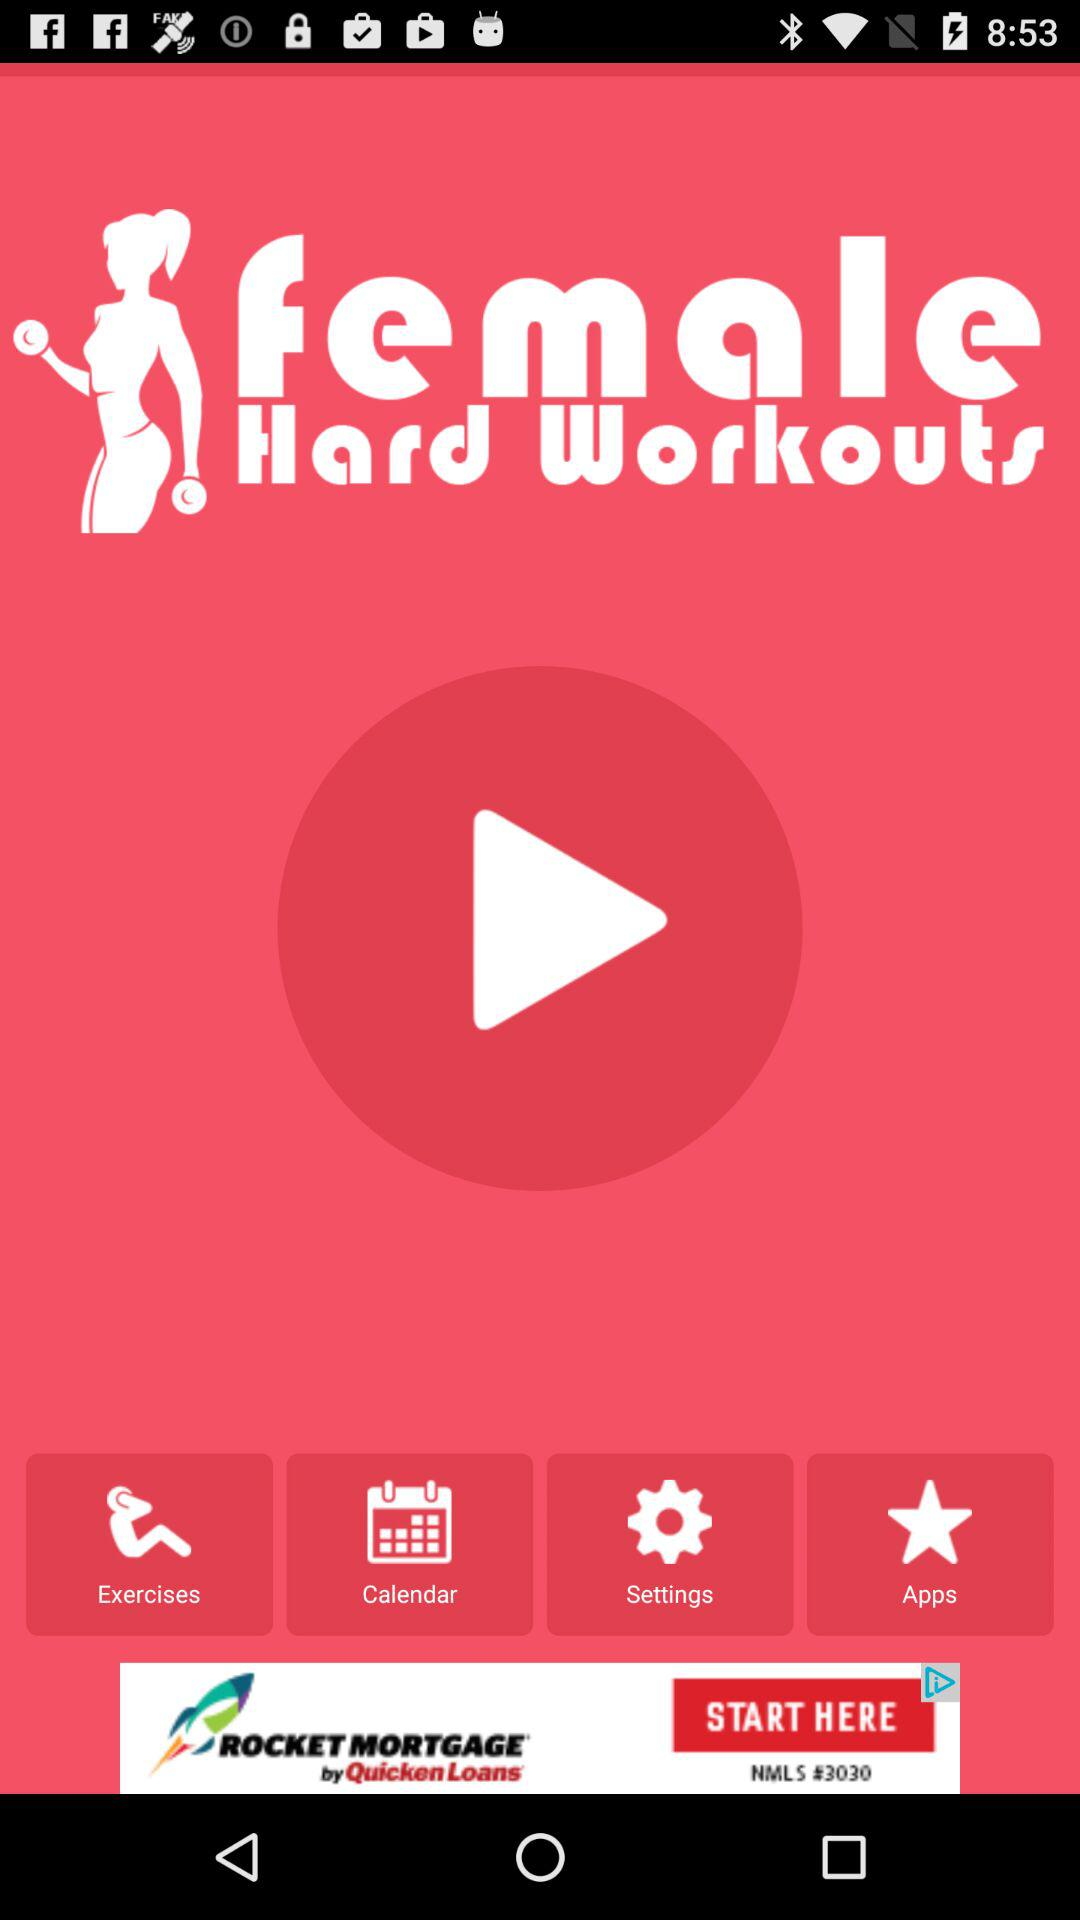What is the application name? The application name is "female Hard Workouts". 